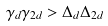<formula> <loc_0><loc_0><loc_500><loc_500>\gamma _ { d } \gamma _ { 2 d } > \Delta _ { d } \Delta _ { 2 d }</formula> 